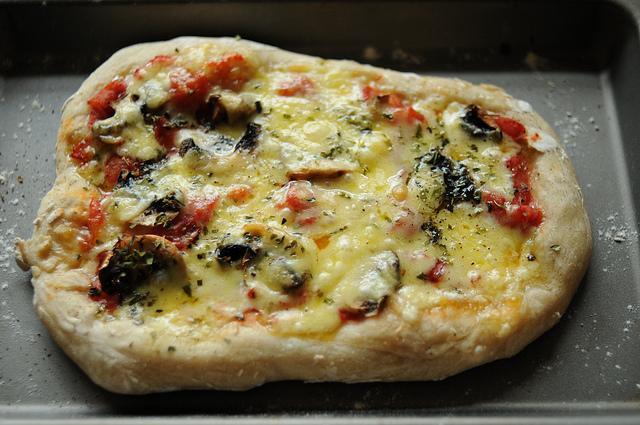How many pizzas can be seen?
Give a very brief answer. 1. 